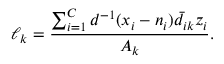Convert formula to latex. <formula><loc_0><loc_0><loc_500><loc_500>\ell _ { k } = \frac { \sum _ { i = 1 } ^ { C } d ^ { - 1 } ( x _ { i } - n _ { i } ) \bar { d } _ { i k } z _ { i } } { A _ { k } } .</formula> 